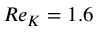<formula> <loc_0><loc_0><loc_500><loc_500>R e _ { K } = 1 . 6</formula> 